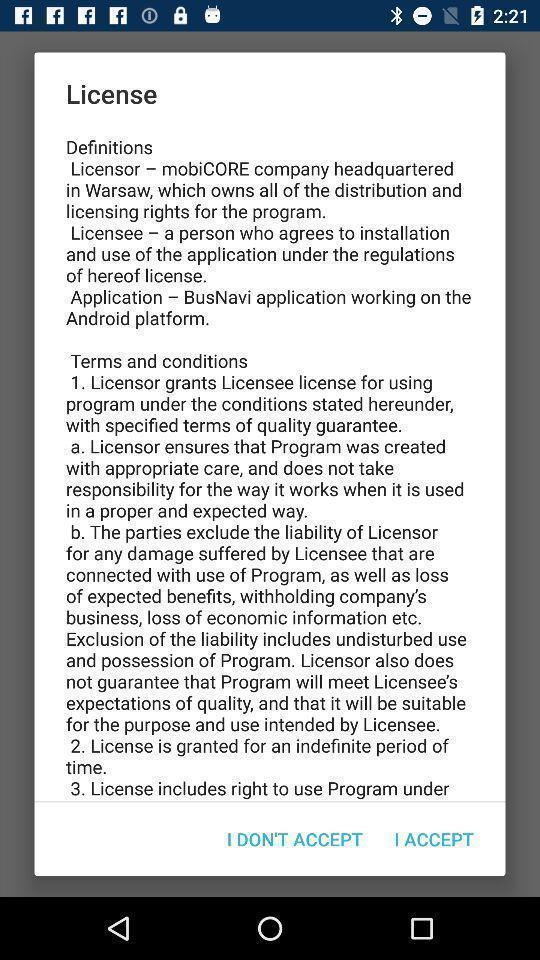Provide a description of this screenshot. Pop-up shows license details. 